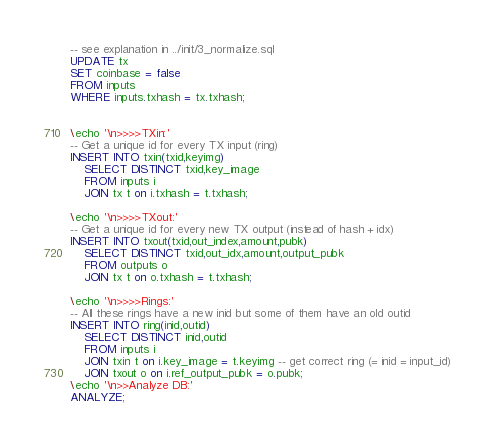<code> <loc_0><loc_0><loc_500><loc_500><_SQL_>-- see explanation in ../init/3_normalize.sql
UPDATE tx
SET coinbase = false
FROM inputs
WHERE inputs.txhash = tx.txhash;


\echo '\n>>>>TXin:'
-- Get a unique id for every TX input (ring)
INSERT INTO txin(txid,keyimg)
	SELECT DISTINCT txid,key_image
	FROM inputs i
	JOIN tx t on i.txhash = t.txhash;

\echo '\n>>>>TXout:'
-- Get a unique id for every new TX output (instead of hash + idx)
INSERT INTO txout(txid,out_index,amount,pubk)
	SELECT DISTINCT txid,out_idx,amount,output_pubk
	FROM outputs o
	JOIN tx t on o.txhash = t.txhash;

\echo '\n>>>>Rings:'
-- All these rings have a new inid but some of them have an old outid
INSERT INTO ring(inid,outid)
	SELECT DISTINCT inid,outid
	FROM inputs i
	JOIN txin t on i.key_image = t.keyimg -- get correct ring (= inid = input_id)
	JOIN txout o on i.ref_output_pubk = o.pubk;
\echo '\n>>Analyze DB:'
ANALYZE;
</code> 